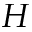<formula> <loc_0><loc_0><loc_500><loc_500>H</formula> 